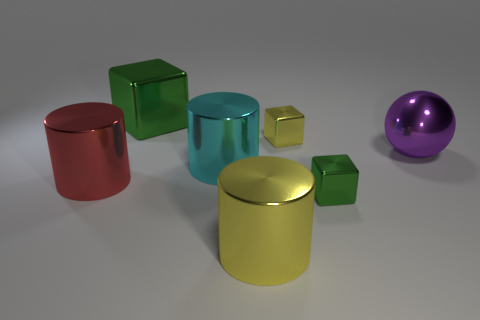Which is the largest object in the scene and what is its color? The largest object in the scene is the yellow metal cylinder located centrally. Its hue is a soft yellow, and it has a reflective surface which captures some of the environment's grey tones. Could this arrangement be representing a specific concept or idea? This arrangement could be interpreted as a study of shapes, colors, and reflections in space. The differing sizes, the contrasting colors, and the individual positioning suggest a sort of harmonious diversity or an exploration of individuality within a shared environment. 